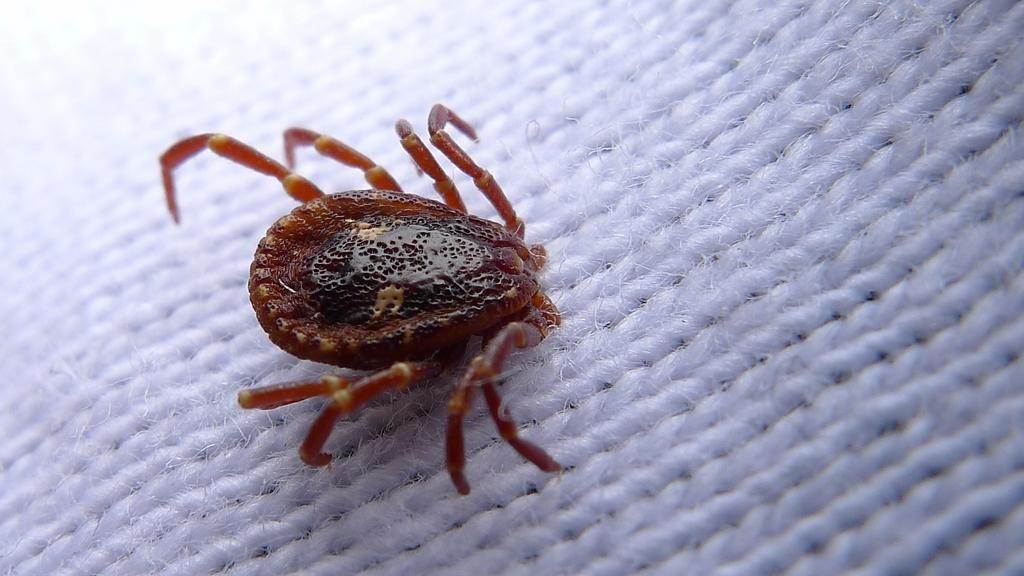What type of creature can be seen in the image? There is an insect in the image. Where is the insect located? The insect is on a cloth. What type of magic is the insect performing in the image? There is no magic or magical activity depicted in the image; it simply shows an insect on a cloth. 